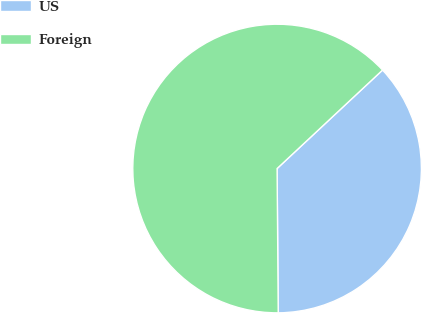Convert chart. <chart><loc_0><loc_0><loc_500><loc_500><pie_chart><fcel>US<fcel>Foreign<nl><fcel>36.83%<fcel>63.17%<nl></chart> 